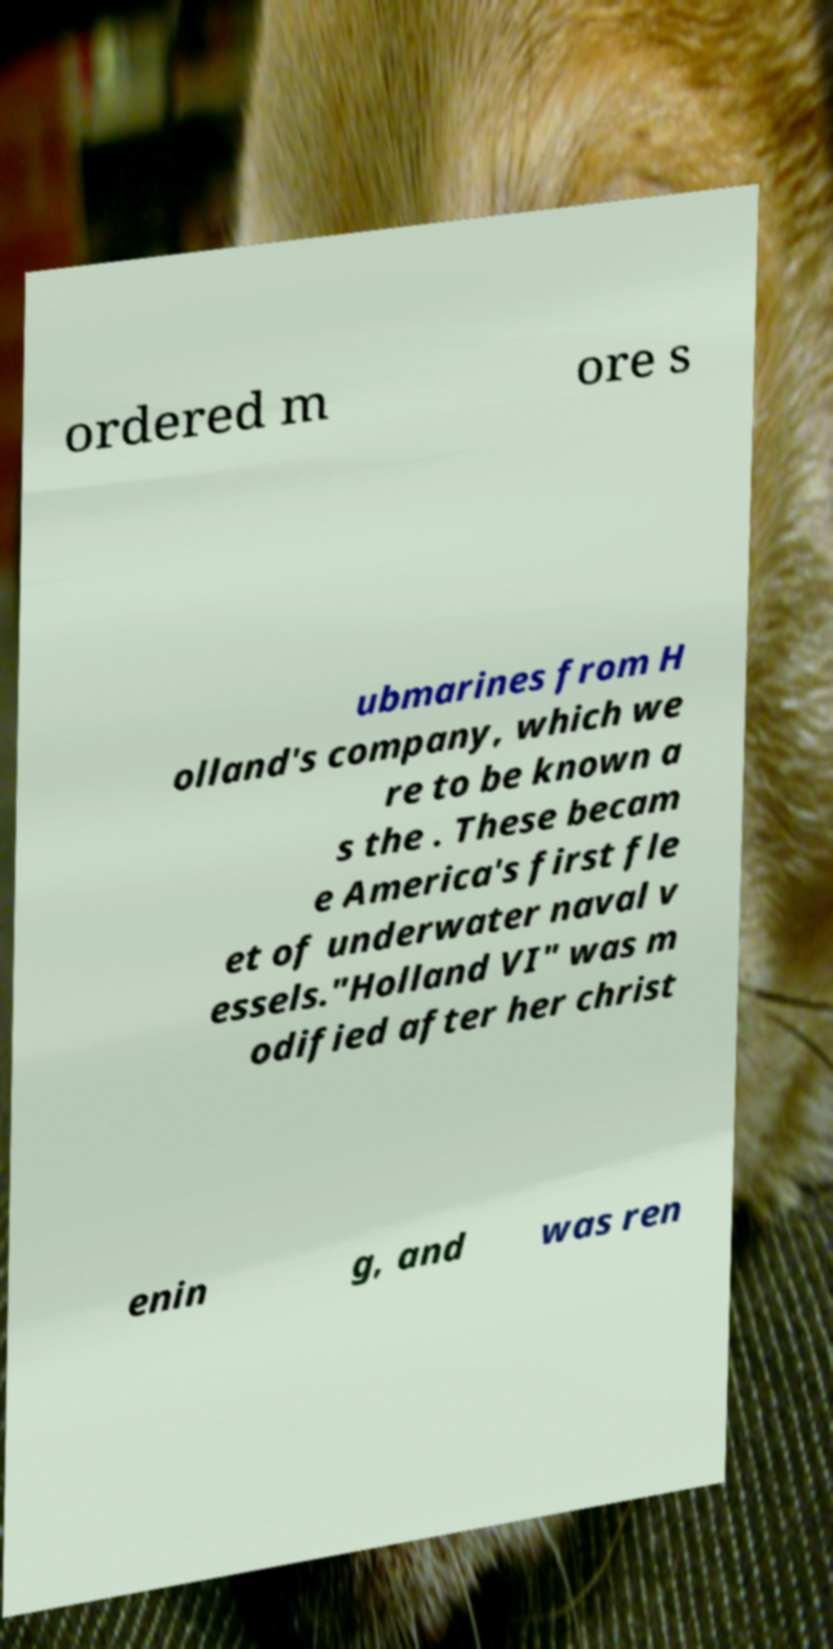Could you extract and type out the text from this image? ordered m ore s ubmarines from H olland's company, which we re to be known a s the . These becam e America's first fle et of underwater naval v essels."Holland VI" was m odified after her christ enin g, and was ren 